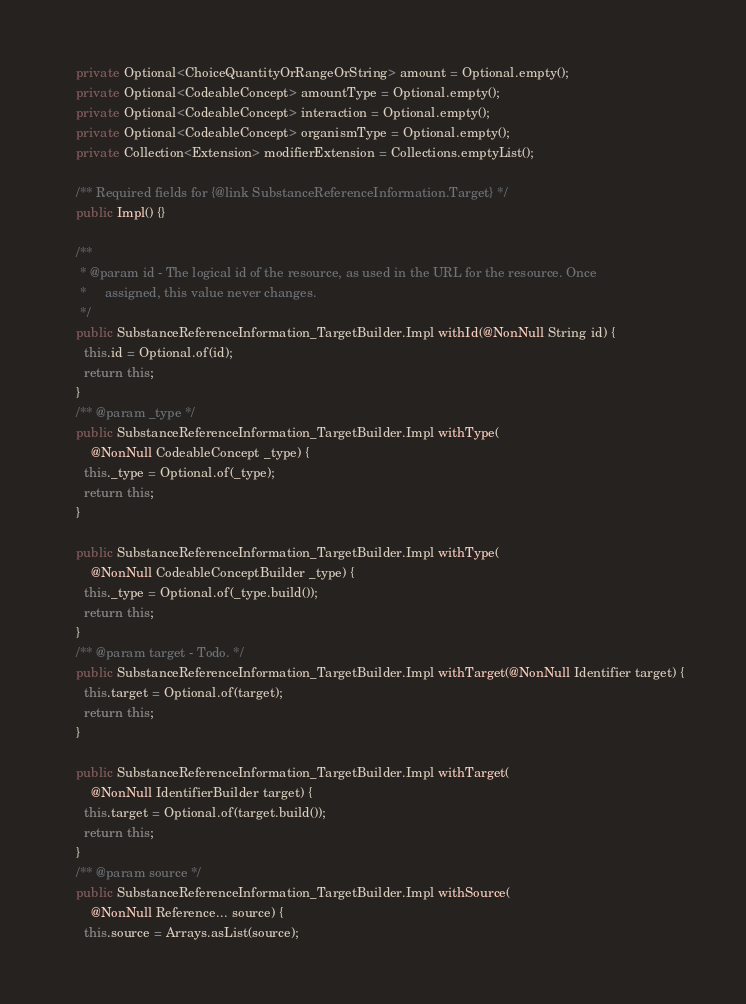Convert code to text. <code><loc_0><loc_0><loc_500><loc_500><_Java_>    private Optional<ChoiceQuantityOrRangeOrString> amount = Optional.empty();
    private Optional<CodeableConcept> amountType = Optional.empty();
    private Optional<CodeableConcept> interaction = Optional.empty();
    private Optional<CodeableConcept> organismType = Optional.empty();
    private Collection<Extension> modifierExtension = Collections.emptyList();

    /** Required fields for {@link SubstanceReferenceInformation.Target} */
    public Impl() {}

    /**
     * @param id - The logical id of the resource, as used in the URL for the resource. Once
     *     assigned, this value never changes.
     */
    public SubstanceReferenceInformation_TargetBuilder.Impl withId(@NonNull String id) {
      this.id = Optional.of(id);
      return this;
    }
    /** @param _type */
    public SubstanceReferenceInformation_TargetBuilder.Impl withType(
        @NonNull CodeableConcept _type) {
      this._type = Optional.of(_type);
      return this;
    }

    public SubstanceReferenceInformation_TargetBuilder.Impl withType(
        @NonNull CodeableConceptBuilder _type) {
      this._type = Optional.of(_type.build());
      return this;
    }
    /** @param target - Todo. */
    public SubstanceReferenceInformation_TargetBuilder.Impl withTarget(@NonNull Identifier target) {
      this.target = Optional.of(target);
      return this;
    }

    public SubstanceReferenceInformation_TargetBuilder.Impl withTarget(
        @NonNull IdentifierBuilder target) {
      this.target = Optional.of(target.build());
      return this;
    }
    /** @param source */
    public SubstanceReferenceInformation_TargetBuilder.Impl withSource(
        @NonNull Reference... source) {
      this.source = Arrays.asList(source);</code> 